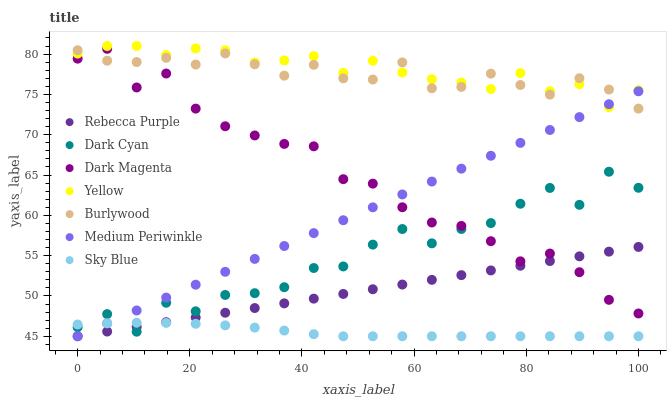Does Sky Blue have the minimum area under the curve?
Answer yes or no. Yes. Does Yellow have the maximum area under the curve?
Answer yes or no. Yes. Does Burlywood have the minimum area under the curve?
Answer yes or no. No. Does Burlywood have the maximum area under the curve?
Answer yes or no. No. Is Medium Periwinkle the smoothest?
Answer yes or no. Yes. Is Dark Cyan the roughest?
Answer yes or no. Yes. Is Burlywood the smoothest?
Answer yes or no. No. Is Burlywood the roughest?
Answer yes or no. No. Does Medium Periwinkle have the lowest value?
Answer yes or no. Yes. Does Burlywood have the lowest value?
Answer yes or no. No. Does Yellow have the highest value?
Answer yes or no. Yes. Does Burlywood have the highest value?
Answer yes or no. No. Is Sky Blue less than Yellow?
Answer yes or no. Yes. Is Yellow greater than Dark Cyan?
Answer yes or no. Yes. Does Sky Blue intersect Rebecca Purple?
Answer yes or no. Yes. Is Sky Blue less than Rebecca Purple?
Answer yes or no. No. Is Sky Blue greater than Rebecca Purple?
Answer yes or no. No. Does Sky Blue intersect Yellow?
Answer yes or no. No. 